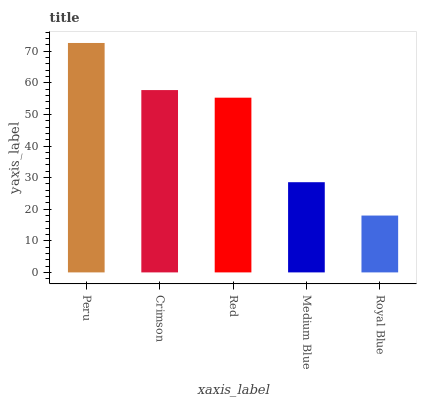Is Royal Blue the minimum?
Answer yes or no. Yes. Is Peru the maximum?
Answer yes or no. Yes. Is Crimson the minimum?
Answer yes or no. No. Is Crimson the maximum?
Answer yes or no. No. Is Peru greater than Crimson?
Answer yes or no. Yes. Is Crimson less than Peru?
Answer yes or no. Yes. Is Crimson greater than Peru?
Answer yes or no. No. Is Peru less than Crimson?
Answer yes or no. No. Is Red the high median?
Answer yes or no. Yes. Is Red the low median?
Answer yes or no. Yes. Is Crimson the high median?
Answer yes or no. No. Is Peru the low median?
Answer yes or no. No. 